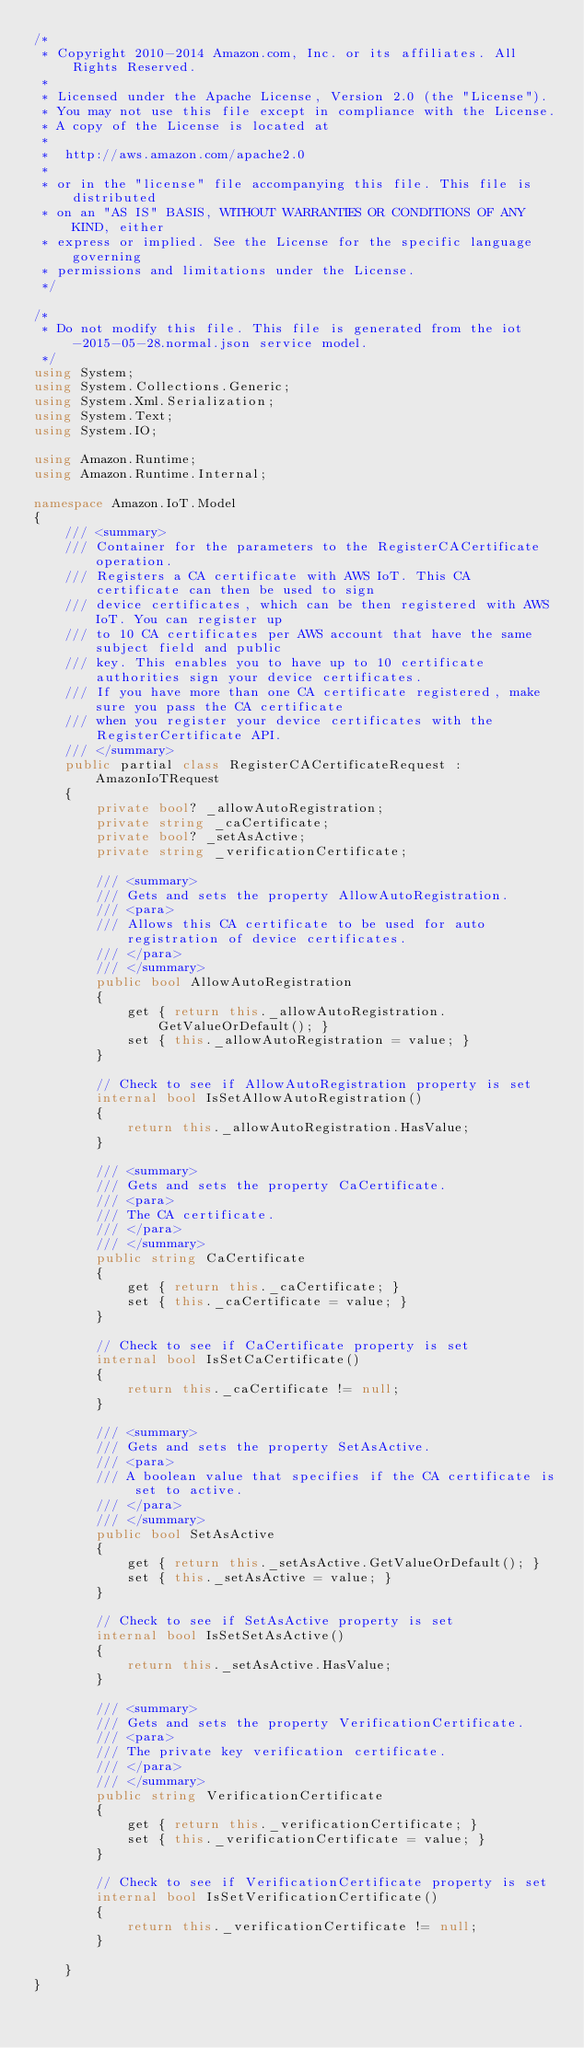<code> <loc_0><loc_0><loc_500><loc_500><_C#_>/*
 * Copyright 2010-2014 Amazon.com, Inc. or its affiliates. All Rights Reserved.
 * 
 * Licensed under the Apache License, Version 2.0 (the "License").
 * You may not use this file except in compliance with the License.
 * A copy of the License is located at
 * 
 *  http://aws.amazon.com/apache2.0
 * 
 * or in the "license" file accompanying this file. This file is distributed
 * on an "AS IS" BASIS, WITHOUT WARRANTIES OR CONDITIONS OF ANY KIND, either
 * express or implied. See the License for the specific language governing
 * permissions and limitations under the License.
 */

/*
 * Do not modify this file. This file is generated from the iot-2015-05-28.normal.json service model.
 */
using System;
using System.Collections.Generic;
using System.Xml.Serialization;
using System.Text;
using System.IO;

using Amazon.Runtime;
using Amazon.Runtime.Internal;

namespace Amazon.IoT.Model
{
    /// <summary>
    /// Container for the parameters to the RegisterCACertificate operation.
    /// Registers a CA certificate with AWS IoT. This CA certificate can then be used to sign
    /// device certificates, which can be then registered with AWS IoT. You can register up
    /// to 10 CA certificates per AWS account that have the same subject field and public
    /// key. This enables you to have up to 10 certificate authorities sign your device certificates.
    /// If you have more than one CA certificate registered, make sure you pass the CA certificate
    /// when you register your device certificates with the RegisterCertificate API.
    /// </summary>
    public partial class RegisterCACertificateRequest : AmazonIoTRequest
    {
        private bool? _allowAutoRegistration;
        private string _caCertificate;
        private bool? _setAsActive;
        private string _verificationCertificate;

        /// <summary>
        /// Gets and sets the property AllowAutoRegistration. 
        /// <para>
        /// Allows this CA certificate to be used for auto registration of device certificates.
        /// </para>
        /// </summary>
        public bool AllowAutoRegistration
        {
            get { return this._allowAutoRegistration.GetValueOrDefault(); }
            set { this._allowAutoRegistration = value; }
        }

        // Check to see if AllowAutoRegistration property is set
        internal bool IsSetAllowAutoRegistration()
        {
            return this._allowAutoRegistration.HasValue; 
        }

        /// <summary>
        /// Gets and sets the property CaCertificate. 
        /// <para>
        /// The CA certificate.
        /// </para>
        /// </summary>
        public string CaCertificate
        {
            get { return this._caCertificate; }
            set { this._caCertificate = value; }
        }

        // Check to see if CaCertificate property is set
        internal bool IsSetCaCertificate()
        {
            return this._caCertificate != null;
        }

        /// <summary>
        /// Gets and sets the property SetAsActive. 
        /// <para>
        /// A boolean value that specifies if the CA certificate is set to active.
        /// </para>
        /// </summary>
        public bool SetAsActive
        {
            get { return this._setAsActive.GetValueOrDefault(); }
            set { this._setAsActive = value; }
        }

        // Check to see if SetAsActive property is set
        internal bool IsSetSetAsActive()
        {
            return this._setAsActive.HasValue; 
        }

        /// <summary>
        /// Gets and sets the property VerificationCertificate. 
        /// <para>
        /// The private key verification certificate.
        /// </para>
        /// </summary>
        public string VerificationCertificate
        {
            get { return this._verificationCertificate; }
            set { this._verificationCertificate = value; }
        }

        // Check to see if VerificationCertificate property is set
        internal bool IsSetVerificationCertificate()
        {
            return this._verificationCertificate != null;
        }

    }
}</code> 